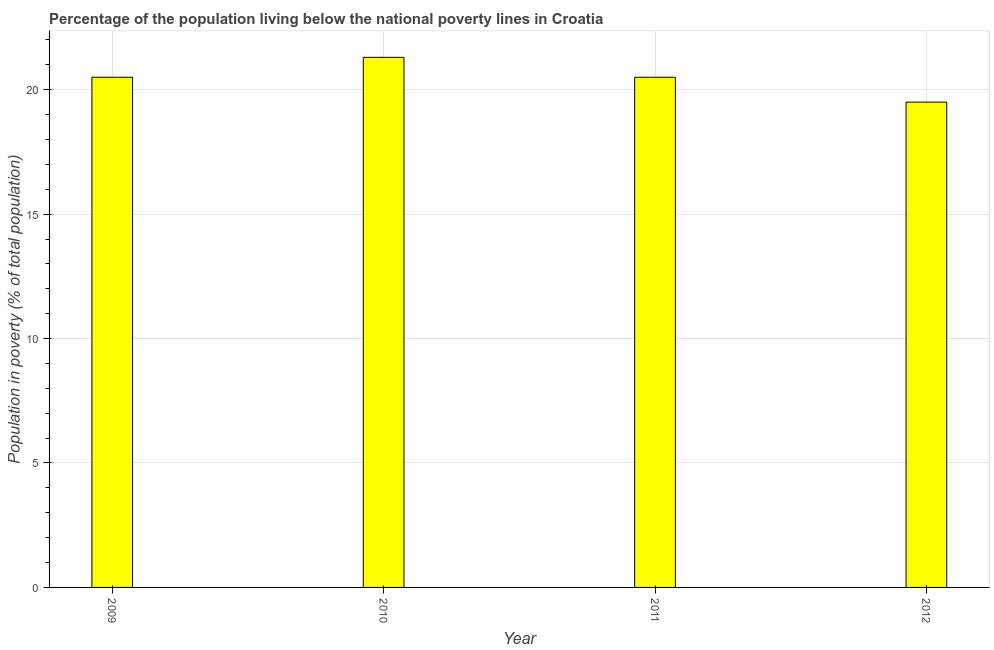Does the graph contain any zero values?
Ensure brevity in your answer.  No. Does the graph contain grids?
Make the answer very short. Yes. What is the title of the graph?
Your answer should be very brief. Percentage of the population living below the national poverty lines in Croatia. What is the label or title of the Y-axis?
Make the answer very short. Population in poverty (% of total population). What is the percentage of population living below poverty line in 2010?
Your answer should be compact. 21.3. Across all years, what is the maximum percentage of population living below poverty line?
Ensure brevity in your answer.  21.3. In which year was the percentage of population living below poverty line maximum?
Your answer should be very brief. 2010. In which year was the percentage of population living below poverty line minimum?
Offer a terse response. 2012. What is the sum of the percentage of population living below poverty line?
Offer a terse response. 81.8. What is the average percentage of population living below poverty line per year?
Your answer should be very brief. 20.45. In how many years, is the percentage of population living below poverty line greater than 20 %?
Make the answer very short. 3. Do a majority of the years between 2011 and 2010 (inclusive) have percentage of population living below poverty line greater than 17 %?
Your response must be concise. No. What is the ratio of the percentage of population living below poverty line in 2009 to that in 2010?
Make the answer very short. 0.96. Is the percentage of population living below poverty line in 2009 less than that in 2011?
Your response must be concise. No. What is the difference between the highest and the second highest percentage of population living below poverty line?
Provide a short and direct response. 0.8. Is the sum of the percentage of population living below poverty line in 2010 and 2011 greater than the maximum percentage of population living below poverty line across all years?
Your response must be concise. Yes. What is the difference between the highest and the lowest percentage of population living below poverty line?
Offer a very short reply. 1.8. Are all the bars in the graph horizontal?
Your answer should be compact. No. How many years are there in the graph?
Your answer should be compact. 4. What is the difference between two consecutive major ticks on the Y-axis?
Ensure brevity in your answer.  5. What is the Population in poverty (% of total population) of 2010?
Offer a very short reply. 21.3. What is the Population in poverty (% of total population) of 2012?
Give a very brief answer. 19.5. What is the difference between the Population in poverty (% of total population) in 2009 and 2010?
Offer a terse response. -0.8. What is the difference between the Population in poverty (% of total population) in 2009 and 2011?
Make the answer very short. 0. What is the difference between the Population in poverty (% of total population) in 2010 and 2011?
Offer a terse response. 0.8. What is the difference between the Population in poverty (% of total population) in 2010 and 2012?
Keep it short and to the point. 1.8. What is the ratio of the Population in poverty (% of total population) in 2009 to that in 2012?
Your answer should be compact. 1.05. What is the ratio of the Population in poverty (% of total population) in 2010 to that in 2011?
Your answer should be compact. 1.04. What is the ratio of the Population in poverty (% of total population) in 2010 to that in 2012?
Provide a succinct answer. 1.09. What is the ratio of the Population in poverty (% of total population) in 2011 to that in 2012?
Keep it short and to the point. 1.05. 